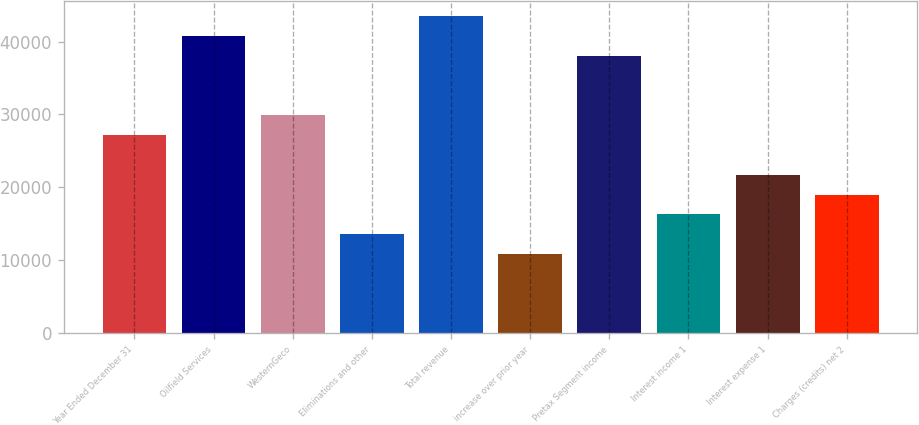<chart> <loc_0><loc_0><loc_500><loc_500><bar_chart><fcel>Year Ended December 31<fcel>Oilfield Services<fcel>WesternGeco<fcel>Eliminations and other<fcel>Total revenue<fcel>increase over prior year<fcel>Pretax Segment income<fcel>Interest income 1<fcel>Interest expense 1<fcel>Charges (credits) net 2<nl><fcel>27163<fcel>40744.1<fcel>29879.3<fcel>13581.9<fcel>43460.4<fcel>10865.7<fcel>38027.9<fcel>16298.2<fcel>21730.6<fcel>19014.4<nl></chart> 